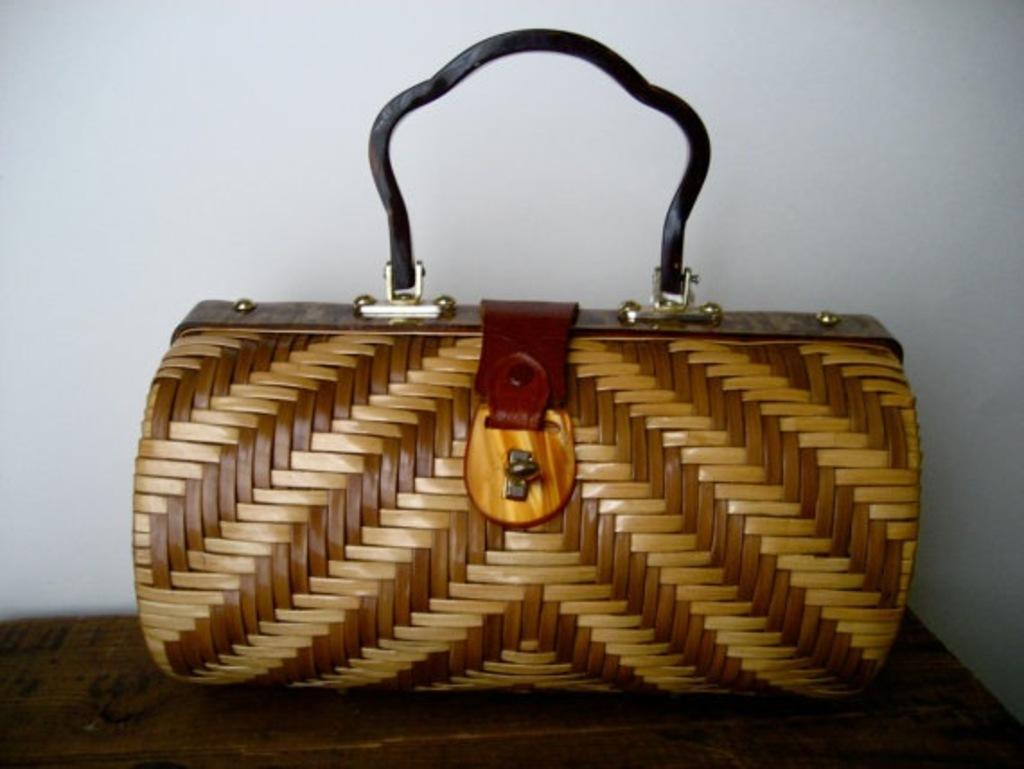What type of accessory is present in the image? There is a brown color handbag in the image. Can you describe the color of the handbag? The handbag is brown in color. How many baseballs are inside the handbag in the image? There is no mention of baseballs or any other items inside the handbag in the image, so we cannot determine their quantity. 